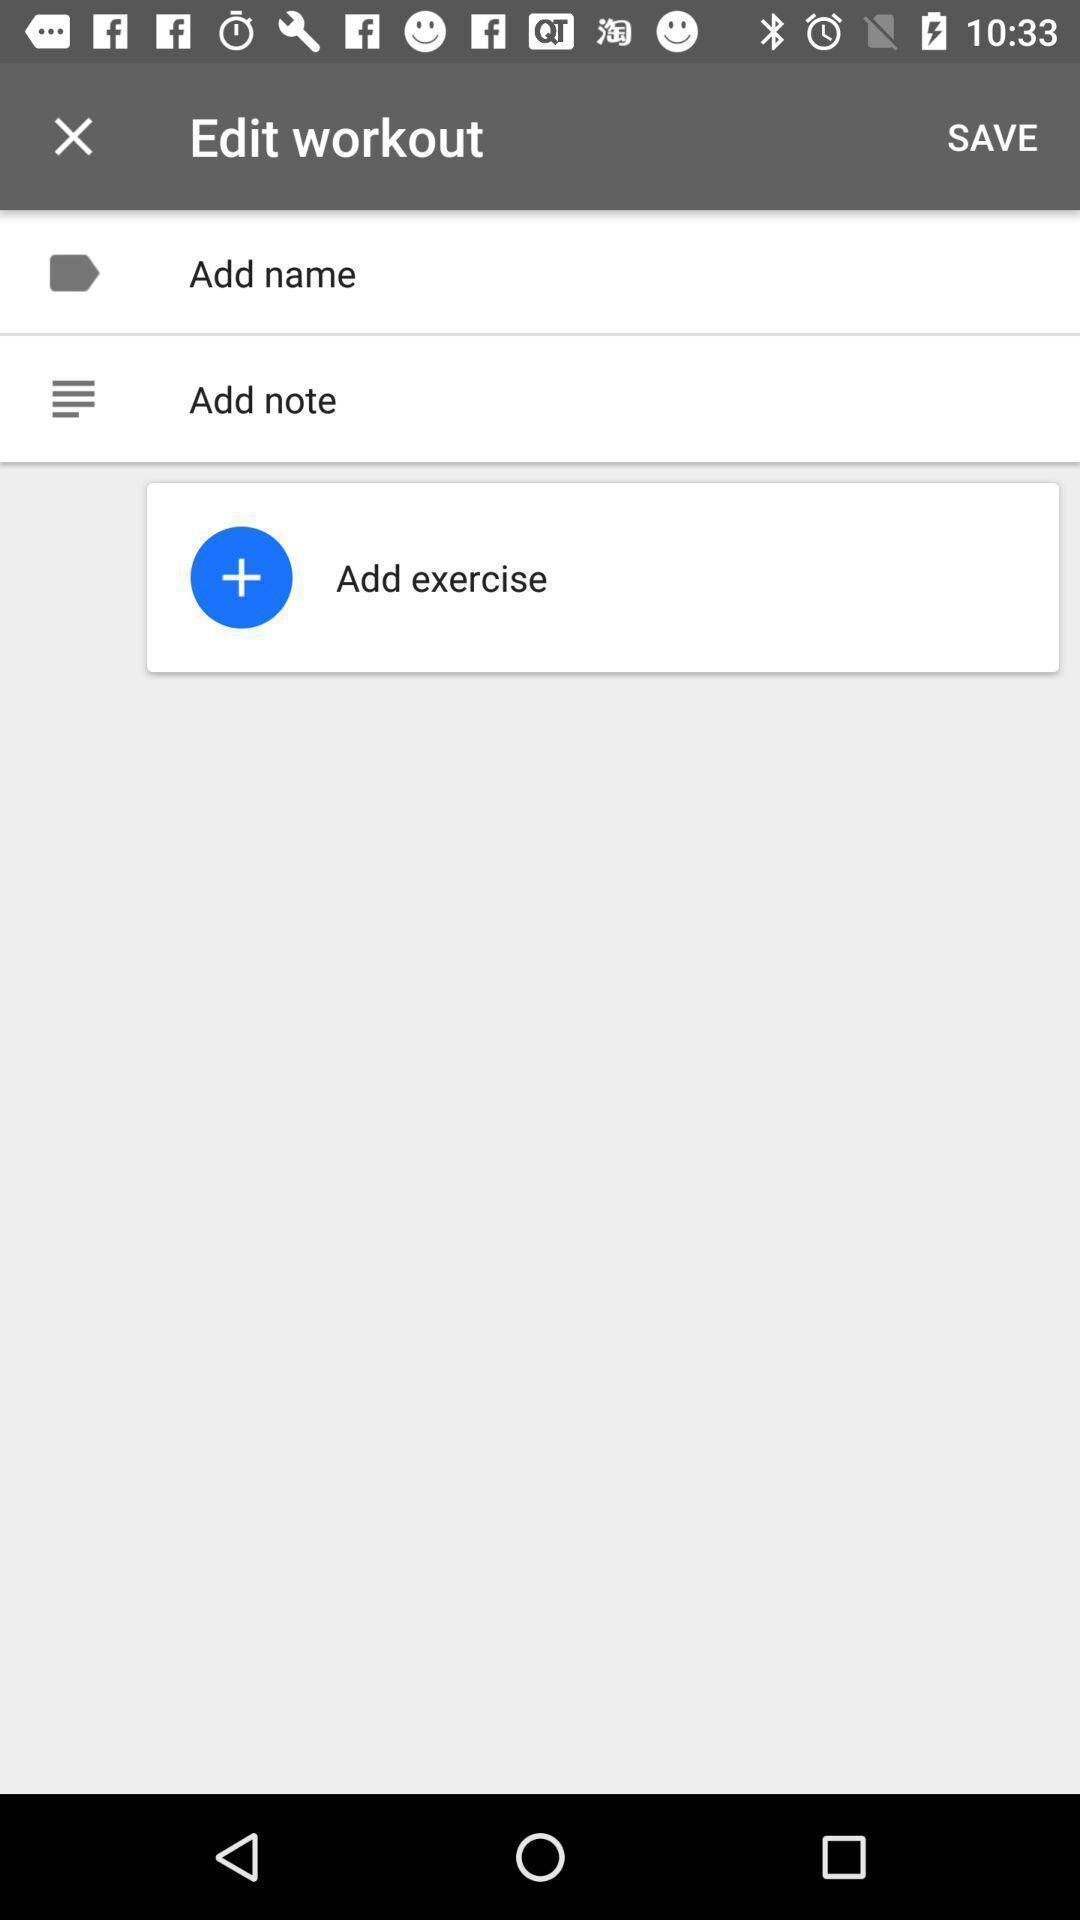Give me a narrative description of this picture. Screen shows to edit work out. 